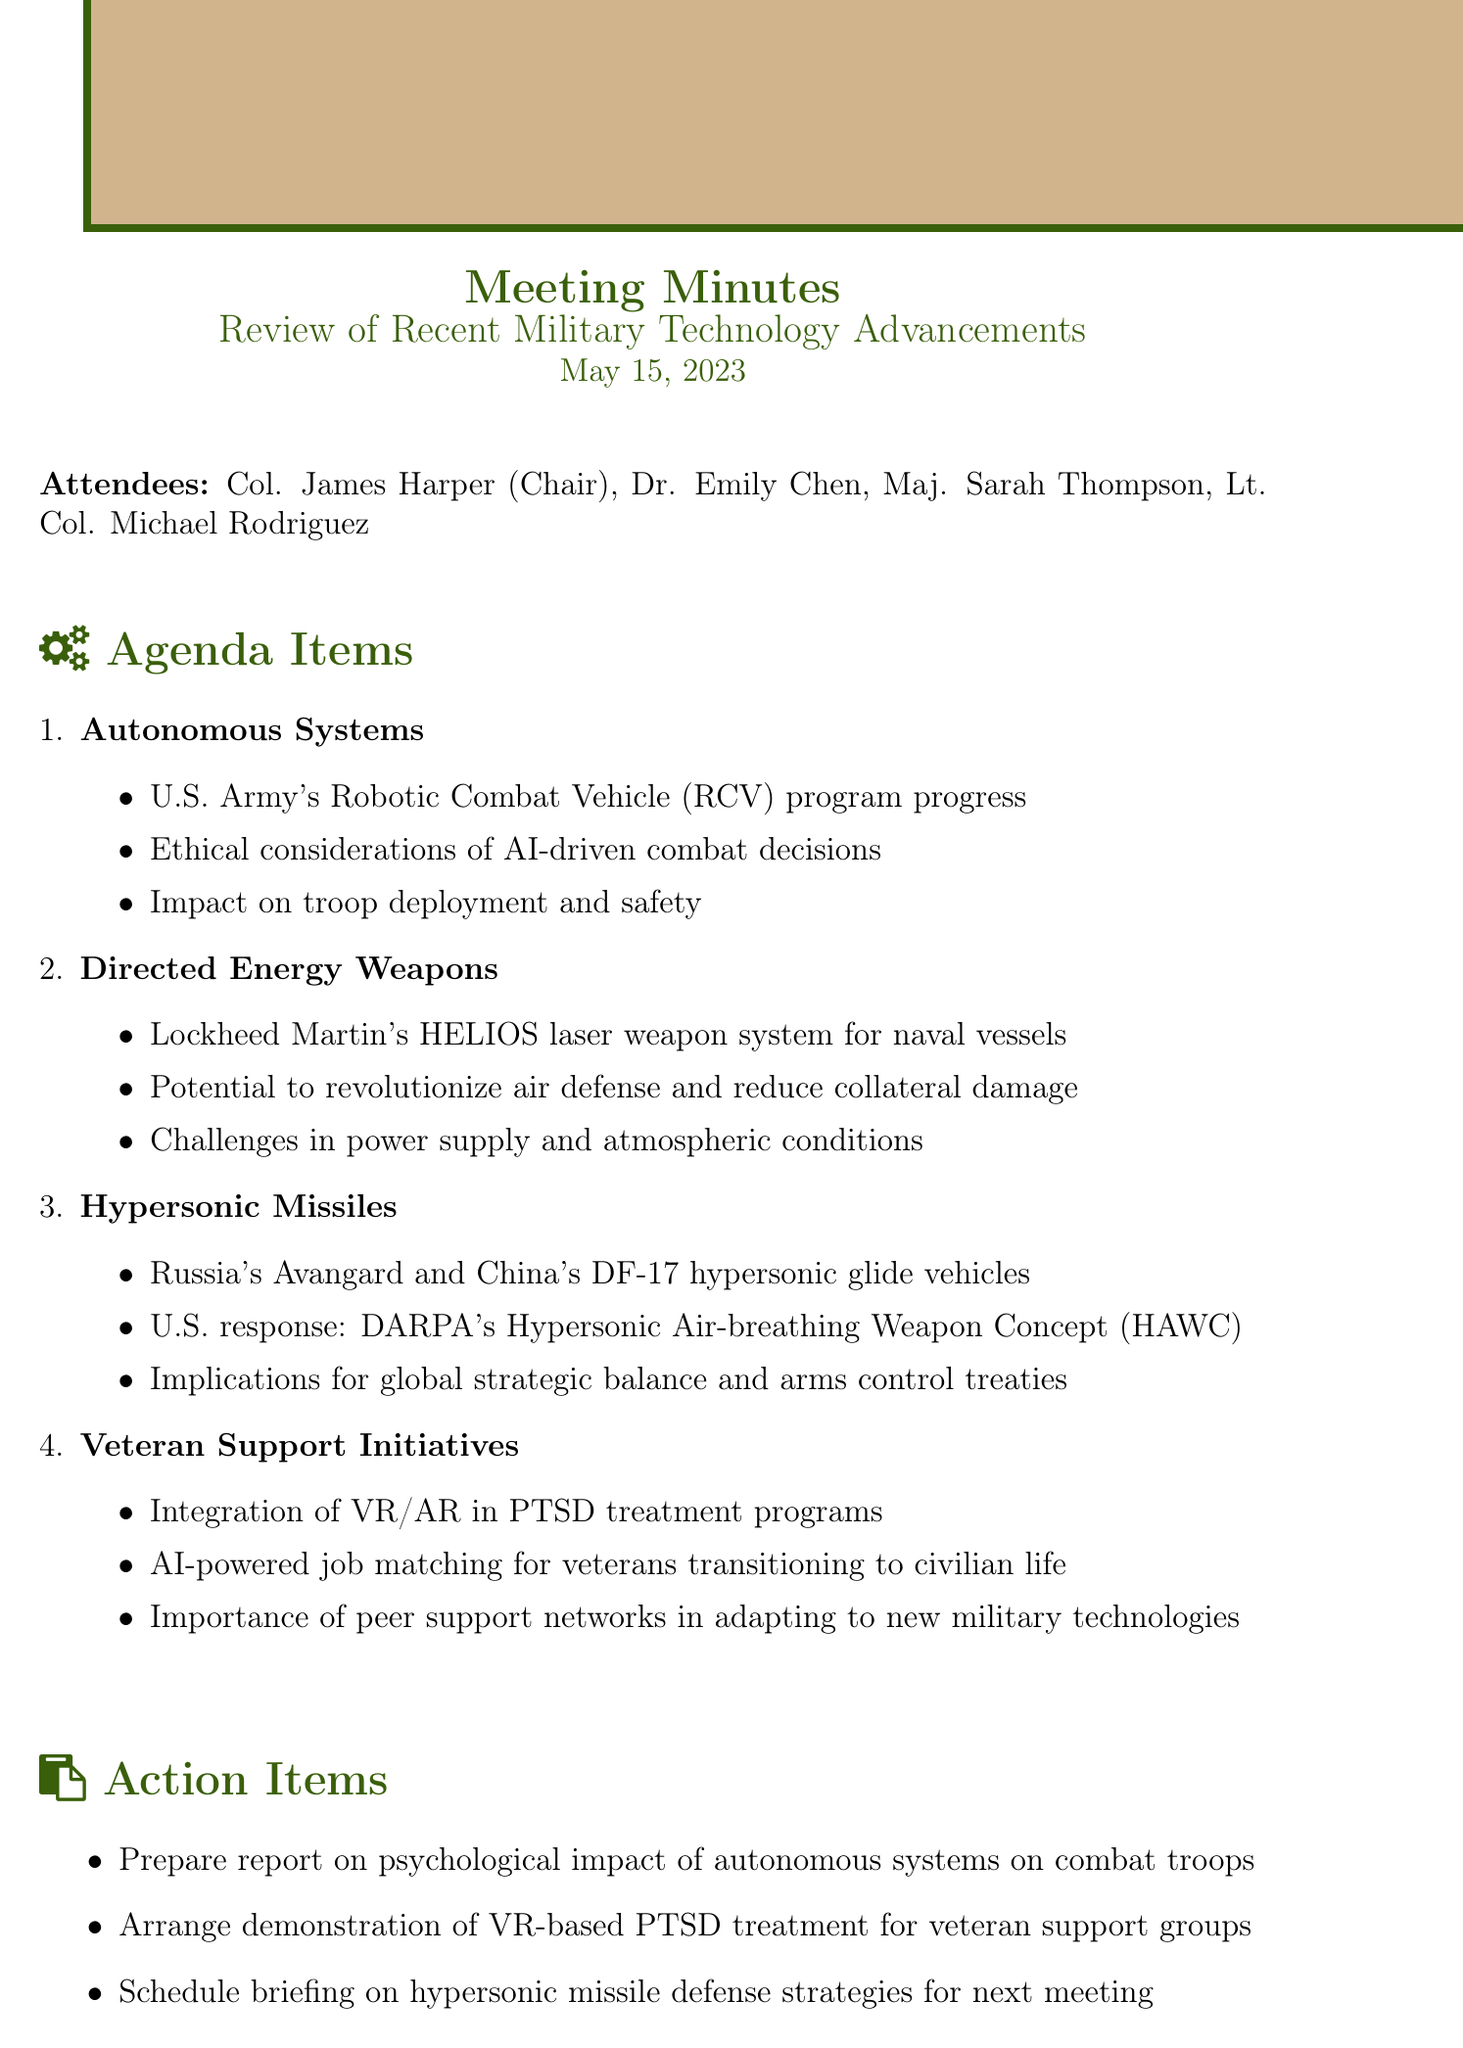What is the date of the meeting? The date of the meeting is explicitly mentioned in the document under the header.
Answer: May 15, 2023 Who is the chair of the meeting? The chair of the meeting is mentioned in the attendees section.
Answer: Col. James Harper What is one initiative discussed for veteran support? The document lists several initiatives in the veteran support section that were discussed.
Answer: Integration of VR/AR in PTSD treatment programs What type of weapon system is HELIOS? The HELIOS system is categorized under one of the agenda items focusing on military technology advancements.
Answer: Laser weapon system What are the implications of hypersonic missiles mentioned? This relates to the broader impact discussed on global strategic balance, requiring synthesis of multiple key points.
Answer: Global strategic balance and arms control treaties What action item involves demonstrating VR technology? The action items section outlines tasks that need to be arranged or prepared.
Answer: Arrange demonstration of VR-based PTSD treatment for veteran support groups Which two countries have hypersonic glide vehicles mentioned? This information can be found in the hypersonic missiles section that lists specific countries.
Answer: Russia and China How many attendees are listed in the document? The number of attendees can be derived from the list provided at the beginning of the document.
Answer: Four 